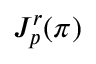Convert formula to latex. <formula><loc_0><loc_0><loc_500><loc_500>J _ { p } ^ { r } ( \pi )</formula> 